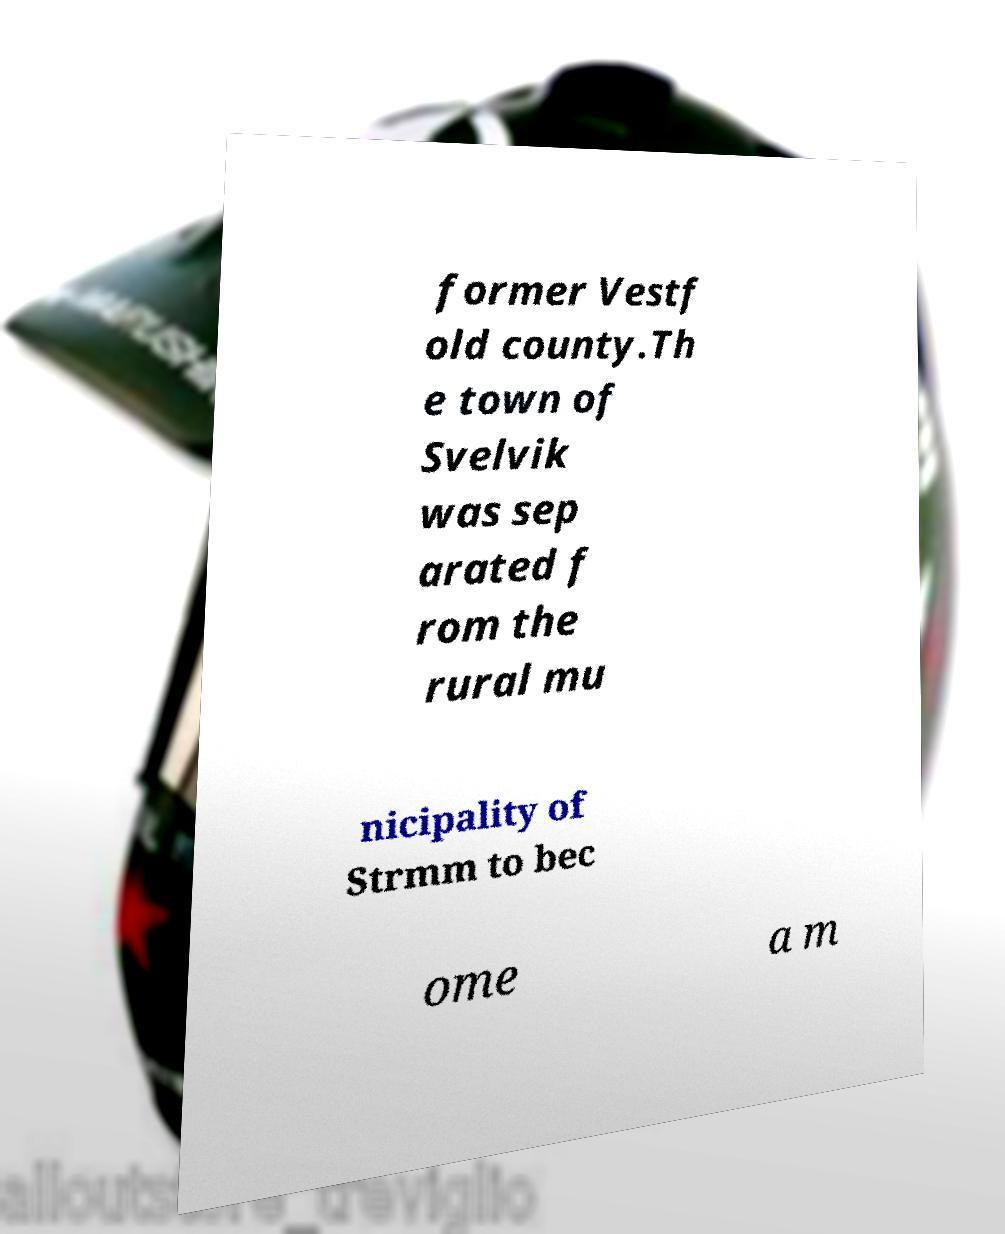What messages or text are displayed in this image? I need them in a readable, typed format. former Vestf old county.Th e town of Svelvik was sep arated f rom the rural mu nicipality of Strmm to bec ome a m 